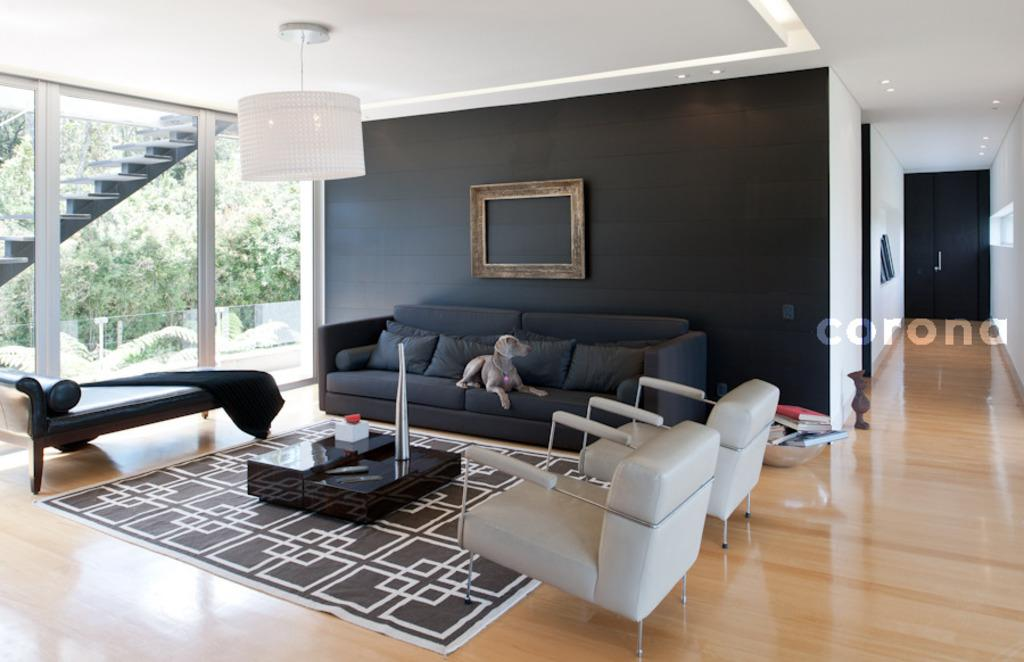What type of furniture is in the image? There is a sofa in the image. What is sitting on the sofa? A dog is sitting on the sofa. What other piece of furniture is in the image? There is a table in the image. What type of lighting fixture is hanging in the image? A chandelier is hanging in the image. How many snails are crawling on the chandelier in the image? There are no snails present in the image; it features a dog sitting on a sofa, a table, and a chandelier. Can you tell me what the dog is saying to the horse in the image? There is no horse present in the image, and therefore no conversation between the dog and a horse can be observed. 